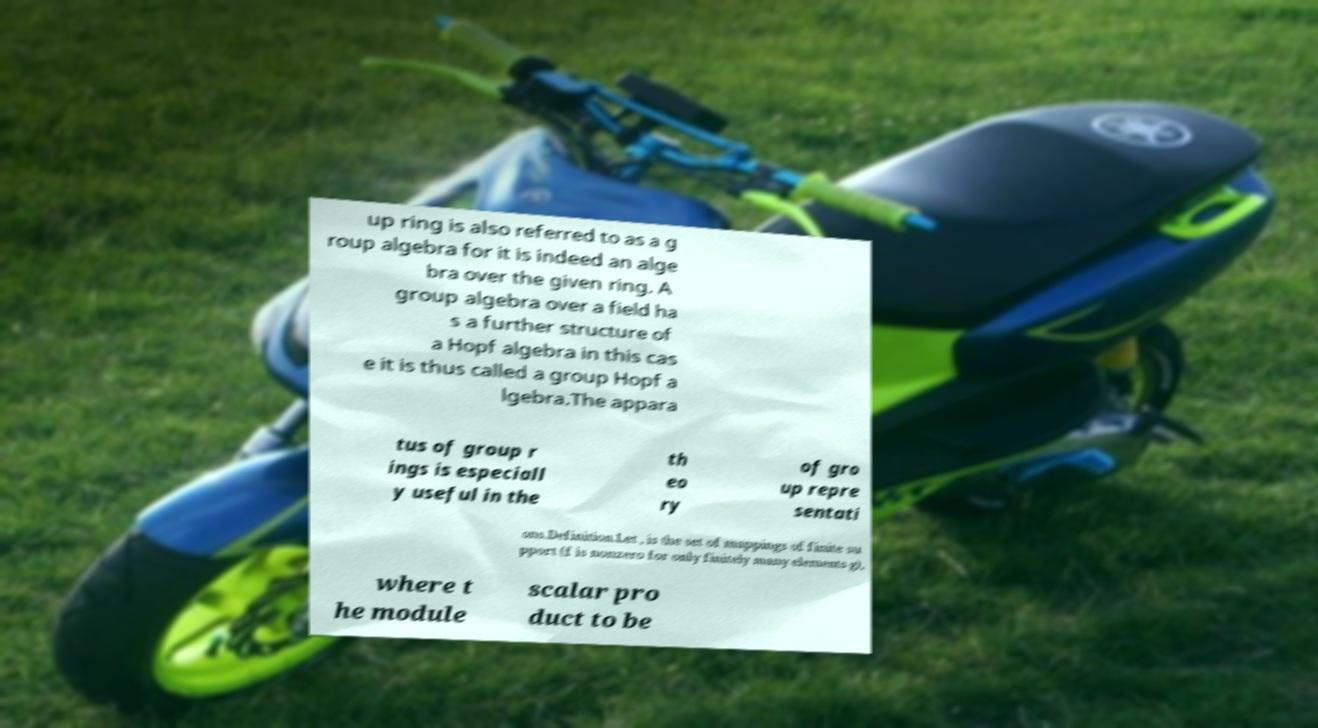Can you accurately transcribe the text from the provided image for me? up ring is also referred to as a g roup algebra for it is indeed an alge bra over the given ring. A group algebra over a field ha s a further structure of a Hopf algebra in this cas e it is thus called a group Hopf a lgebra.The appara tus of group r ings is especiall y useful in the th eo ry of gro up repre sentati ons.Definition.Let , is the set of mappings of finite su pport (f is nonzero for only finitely many elements g), where t he module scalar pro duct to be 